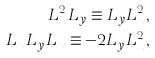Convert formula to latex. <formula><loc_0><loc_0><loc_500><loc_500>L _ { x } ^ { 2 } L _ { y } \equiv L _ { y } L _ { x } ^ { 2 } , \\ L _ { x } L _ { y } L _ { x } \equiv - 2 L _ { y } L _ { x } ^ { 2 } ,</formula> 